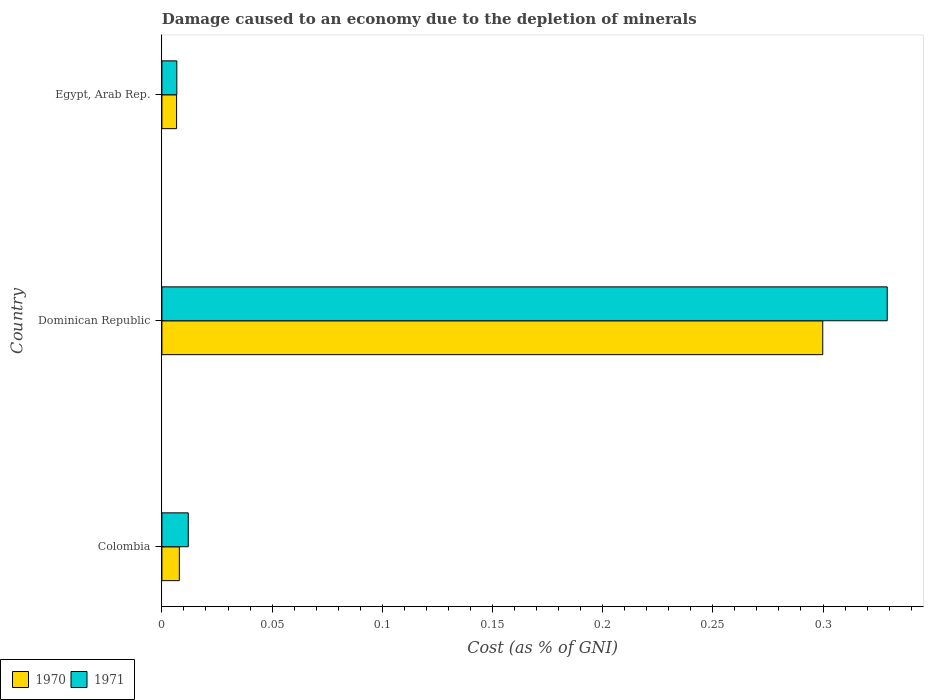How many different coloured bars are there?
Make the answer very short. 2. Are the number of bars per tick equal to the number of legend labels?
Provide a short and direct response. Yes. Are the number of bars on each tick of the Y-axis equal?
Offer a terse response. Yes. How many bars are there on the 3rd tick from the bottom?
Offer a very short reply. 2. What is the label of the 2nd group of bars from the top?
Keep it short and to the point. Dominican Republic. In how many cases, is the number of bars for a given country not equal to the number of legend labels?
Provide a short and direct response. 0. What is the cost of damage caused due to the depletion of minerals in 1971 in Dominican Republic?
Keep it short and to the point. 0.33. Across all countries, what is the maximum cost of damage caused due to the depletion of minerals in 1971?
Ensure brevity in your answer.  0.33. Across all countries, what is the minimum cost of damage caused due to the depletion of minerals in 1970?
Provide a short and direct response. 0.01. In which country was the cost of damage caused due to the depletion of minerals in 1971 maximum?
Your answer should be very brief. Dominican Republic. In which country was the cost of damage caused due to the depletion of minerals in 1971 minimum?
Provide a succinct answer. Egypt, Arab Rep. What is the total cost of damage caused due to the depletion of minerals in 1970 in the graph?
Your response must be concise. 0.31. What is the difference between the cost of damage caused due to the depletion of minerals in 1970 in Colombia and that in Dominican Republic?
Give a very brief answer. -0.29. What is the difference between the cost of damage caused due to the depletion of minerals in 1970 in Egypt, Arab Rep. and the cost of damage caused due to the depletion of minerals in 1971 in Dominican Republic?
Offer a very short reply. -0.32. What is the average cost of damage caused due to the depletion of minerals in 1971 per country?
Give a very brief answer. 0.12. What is the difference between the cost of damage caused due to the depletion of minerals in 1970 and cost of damage caused due to the depletion of minerals in 1971 in Dominican Republic?
Offer a terse response. -0.03. In how many countries, is the cost of damage caused due to the depletion of minerals in 1971 greater than 0.28 %?
Offer a very short reply. 1. What is the ratio of the cost of damage caused due to the depletion of minerals in 1971 in Colombia to that in Egypt, Arab Rep.?
Provide a short and direct response. 1.77. Is the cost of damage caused due to the depletion of minerals in 1971 in Dominican Republic less than that in Egypt, Arab Rep.?
Provide a succinct answer. No. What is the difference between the highest and the second highest cost of damage caused due to the depletion of minerals in 1971?
Offer a terse response. 0.32. What is the difference between the highest and the lowest cost of damage caused due to the depletion of minerals in 1971?
Keep it short and to the point. 0.32. Is the sum of the cost of damage caused due to the depletion of minerals in 1970 in Dominican Republic and Egypt, Arab Rep. greater than the maximum cost of damage caused due to the depletion of minerals in 1971 across all countries?
Offer a very short reply. No. What does the 1st bar from the top in Dominican Republic represents?
Make the answer very short. 1971. What does the 1st bar from the bottom in Colombia represents?
Your response must be concise. 1970. Are all the bars in the graph horizontal?
Make the answer very short. Yes. How many countries are there in the graph?
Offer a very short reply. 3. What is the difference between two consecutive major ticks on the X-axis?
Provide a short and direct response. 0.05. Does the graph contain grids?
Offer a terse response. No. How many legend labels are there?
Provide a short and direct response. 2. How are the legend labels stacked?
Ensure brevity in your answer.  Horizontal. What is the title of the graph?
Keep it short and to the point. Damage caused to an economy due to the depletion of minerals. What is the label or title of the X-axis?
Ensure brevity in your answer.  Cost (as % of GNI). What is the Cost (as % of GNI) of 1970 in Colombia?
Give a very brief answer. 0.01. What is the Cost (as % of GNI) in 1971 in Colombia?
Provide a short and direct response. 0.01. What is the Cost (as % of GNI) of 1970 in Dominican Republic?
Offer a terse response. 0.3. What is the Cost (as % of GNI) of 1971 in Dominican Republic?
Give a very brief answer. 0.33. What is the Cost (as % of GNI) of 1970 in Egypt, Arab Rep.?
Provide a short and direct response. 0.01. What is the Cost (as % of GNI) in 1971 in Egypt, Arab Rep.?
Offer a very short reply. 0.01. Across all countries, what is the maximum Cost (as % of GNI) of 1970?
Provide a succinct answer. 0.3. Across all countries, what is the maximum Cost (as % of GNI) of 1971?
Your answer should be compact. 0.33. Across all countries, what is the minimum Cost (as % of GNI) in 1970?
Make the answer very short. 0.01. Across all countries, what is the minimum Cost (as % of GNI) of 1971?
Your answer should be compact. 0.01. What is the total Cost (as % of GNI) in 1970 in the graph?
Offer a terse response. 0.31. What is the total Cost (as % of GNI) in 1971 in the graph?
Provide a succinct answer. 0.35. What is the difference between the Cost (as % of GNI) in 1970 in Colombia and that in Dominican Republic?
Your answer should be very brief. -0.29. What is the difference between the Cost (as % of GNI) in 1971 in Colombia and that in Dominican Republic?
Your answer should be very brief. -0.32. What is the difference between the Cost (as % of GNI) of 1970 in Colombia and that in Egypt, Arab Rep.?
Your response must be concise. 0. What is the difference between the Cost (as % of GNI) in 1971 in Colombia and that in Egypt, Arab Rep.?
Offer a very short reply. 0.01. What is the difference between the Cost (as % of GNI) of 1970 in Dominican Republic and that in Egypt, Arab Rep.?
Keep it short and to the point. 0.29. What is the difference between the Cost (as % of GNI) of 1971 in Dominican Republic and that in Egypt, Arab Rep.?
Your answer should be very brief. 0.32. What is the difference between the Cost (as % of GNI) in 1970 in Colombia and the Cost (as % of GNI) in 1971 in Dominican Republic?
Offer a terse response. -0.32. What is the difference between the Cost (as % of GNI) of 1970 in Colombia and the Cost (as % of GNI) of 1971 in Egypt, Arab Rep.?
Keep it short and to the point. 0. What is the difference between the Cost (as % of GNI) in 1970 in Dominican Republic and the Cost (as % of GNI) in 1971 in Egypt, Arab Rep.?
Offer a terse response. 0.29. What is the average Cost (as % of GNI) of 1970 per country?
Offer a very short reply. 0.1. What is the average Cost (as % of GNI) of 1971 per country?
Ensure brevity in your answer.  0.12. What is the difference between the Cost (as % of GNI) in 1970 and Cost (as % of GNI) in 1971 in Colombia?
Provide a succinct answer. -0. What is the difference between the Cost (as % of GNI) of 1970 and Cost (as % of GNI) of 1971 in Dominican Republic?
Provide a short and direct response. -0.03. What is the difference between the Cost (as % of GNI) in 1970 and Cost (as % of GNI) in 1971 in Egypt, Arab Rep.?
Offer a terse response. -0. What is the ratio of the Cost (as % of GNI) in 1970 in Colombia to that in Dominican Republic?
Offer a very short reply. 0.03. What is the ratio of the Cost (as % of GNI) of 1971 in Colombia to that in Dominican Republic?
Provide a short and direct response. 0.04. What is the ratio of the Cost (as % of GNI) in 1970 in Colombia to that in Egypt, Arab Rep.?
Give a very brief answer. 1.19. What is the ratio of the Cost (as % of GNI) of 1971 in Colombia to that in Egypt, Arab Rep.?
Provide a short and direct response. 1.77. What is the ratio of the Cost (as % of GNI) in 1970 in Dominican Republic to that in Egypt, Arab Rep.?
Offer a terse response. 45.04. What is the ratio of the Cost (as % of GNI) of 1971 in Dominican Republic to that in Egypt, Arab Rep.?
Provide a succinct answer. 48.57. What is the difference between the highest and the second highest Cost (as % of GNI) of 1970?
Make the answer very short. 0.29. What is the difference between the highest and the second highest Cost (as % of GNI) of 1971?
Your answer should be very brief. 0.32. What is the difference between the highest and the lowest Cost (as % of GNI) of 1970?
Your answer should be compact. 0.29. What is the difference between the highest and the lowest Cost (as % of GNI) of 1971?
Provide a succinct answer. 0.32. 